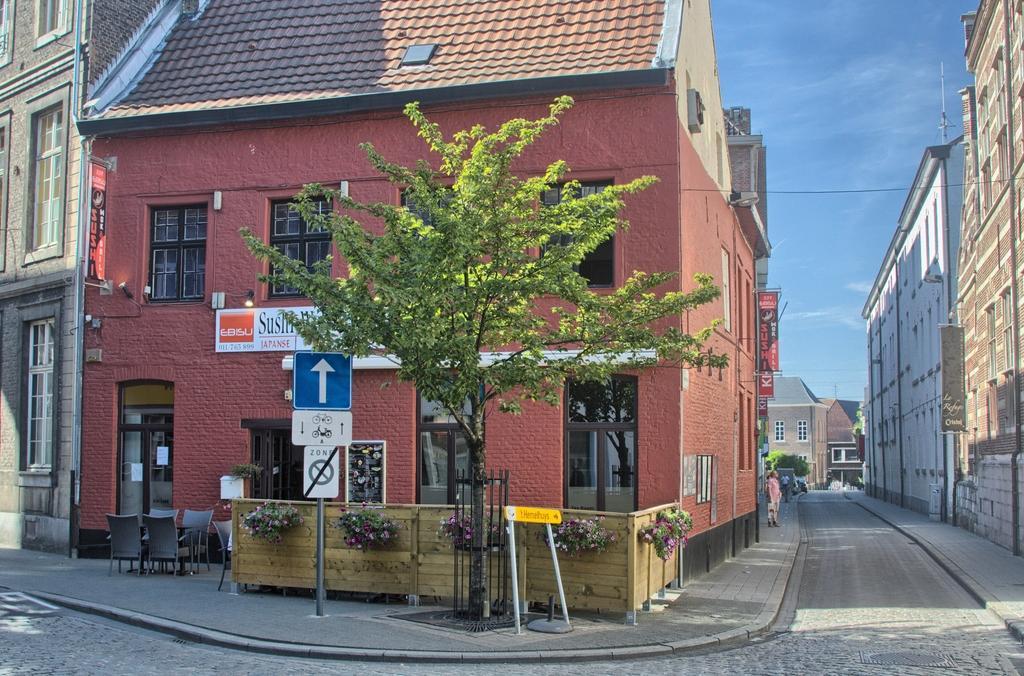In one or two sentences, can you explain what this image depicts? In this image we can see buildings, plants, boards with some text, fence and we can also see a person standing on the road. 